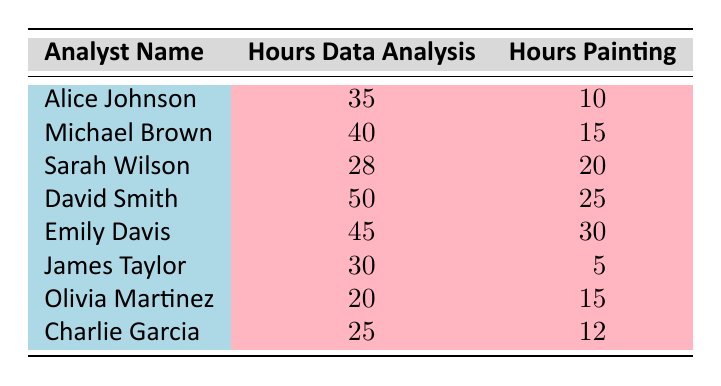What is the total number of hours spent on data analysis by all analysts? To calculate the total hours spent on data analysis, we sum the hours for each analyst: 35 + 40 + 28 + 50 + 45 + 30 + 20 + 25 = 273 hours.
Answer: 273 hours Who spent the most hours on painting? Looking at the "Hours Painting" column, Emily Davis has the highest value of 30 hours.
Answer: Emily Davis Is it true that Sarah Wilson spent more hours painting than James Taylor? Sarah Wilson spent 20 hours on painting while James Taylor spent only 5 hours, thus Sarah spent more.
Answer: Yes What is the average number of hours spent on painting by all analysts? To find the average, sum the painting hours: 10 + 15 + 20 + 25 + 30 + 5 + 15 + 12 = 132 hours. There are 8 analysts, so the average is 132 / 8 = 16.5 hours.
Answer: 16.5 hours Which analyst spent the least amount of time on data analysis? Looking at the "Hours Data Analysis" column, Olivia Martinez spent the least amount of time with 20 hours.
Answer: Olivia Martinez What is the difference between the highest and lowest hours spent on painting? The highest is 30 hours (Emily Davis) and the lowest is 5 hours (James Taylor). The difference is 30 - 5 = 25 hours.
Answer: 25 hours Is it true that the sum of hours spent on painting is less than 100 hours? The sum of hours spent on painting is 132 hours (from a previous calculation), which is greater than 100.
Answer: No How many analysts spent more than 20 hours on data analysis? The analysts who spent more than 20 hours on data analysis are Michael Brown, David Smith, Alice Johnson, and Emily Davis, totaling 4 analysts.
Answer: 4 analysts What is the total time spent on both data analysis and painting by David Smith? David Smith spent 50 hours on data analysis and 25 hours on painting. So, the total is 50 + 25 = 75 hours.
Answer: 75 hours 